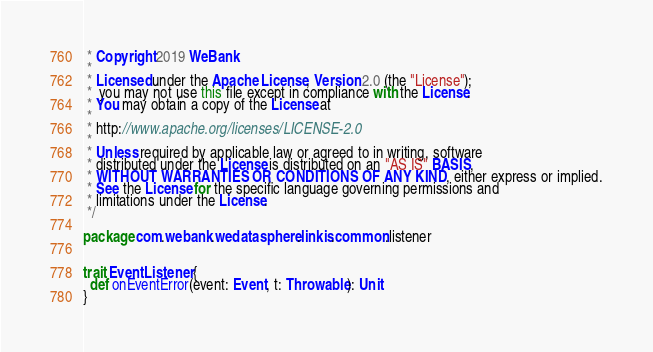<code> <loc_0><loc_0><loc_500><loc_500><_Scala_> * Copyright 2019 WeBank
 *
 * Licensed under the Apache License, Version 2.0 (the "License");
 *  you may not use this file except in compliance with the License.
 * You may obtain a copy of the License at
 *
 * http://www.apache.org/licenses/LICENSE-2.0
 *
 * Unless required by applicable law or agreed to in writing, software
 * distributed under the License is distributed on an "AS IS" BASIS,
 * WITHOUT WARRANTIES OR CONDITIONS OF ANY KIND, either express or implied.
 * See the License for the specific language governing permissions and
 * limitations under the License.
 */

package com.webank.wedatasphere.linkis.common.listener


trait EventListener {
  def onEventError(event: Event, t: Throwable): Unit
}</code> 